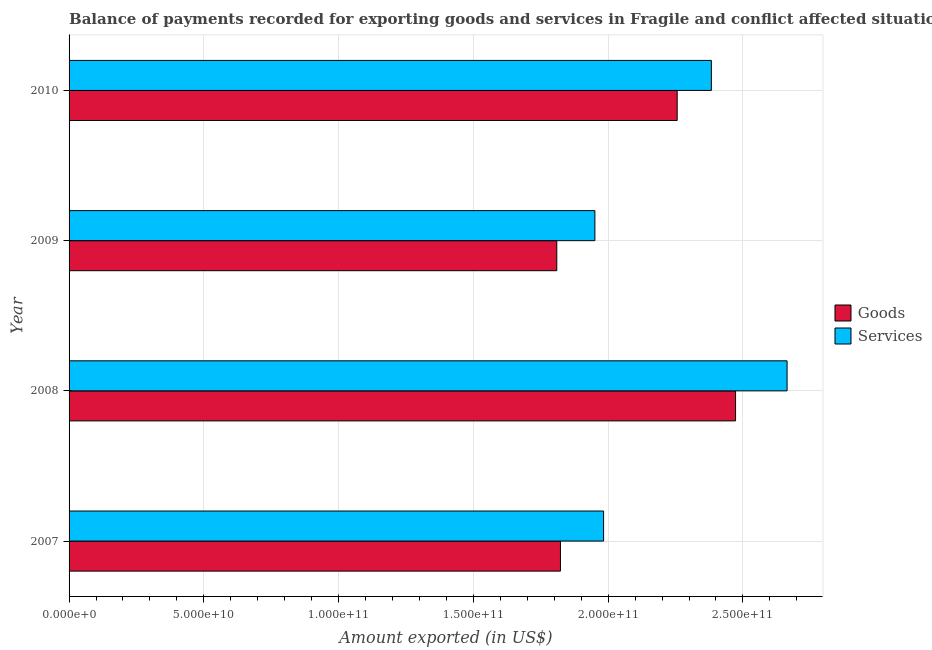How many different coloured bars are there?
Keep it short and to the point. 2. Are the number of bars per tick equal to the number of legend labels?
Keep it short and to the point. Yes. How many bars are there on the 4th tick from the top?
Offer a very short reply. 2. What is the label of the 2nd group of bars from the top?
Your answer should be very brief. 2009. In how many cases, is the number of bars for a given year not equal to the number of legend labels?
Your response must be concise. 0. What is the amount of services exported in 2010?
Your answer should be very brief. 2.38e+11. Across all years, what is the maximum amount of goods exported?
Ensure brevity in your answer.  2.47e+11. Across all years, what is the minimum amount of goods exported?
Offer a very short reply. 1.81e+11. What is the total amount of goods exported in the graph?
Provide a short and direct response. 8.36e+11. What is the difference between the amount of goods exported in 2008 and that in 2010?
Give a very brief answer. 2.17e+1. What is the difference between the amount of goods exported in 2009 and the amount of services exported in 2008?
Offer a very short reply. -8.54e+1. What is the average amount of services exported per year?
Ensure brevity in your answer.  2.25e+11. In the year 2008, what is the difference between the amount of goods exported and amount of services exported?
Keep it short and to the point. -1.91e+1. In how many years, is the amount of goods exported greater than 50000000000 US$?
Keep it short and to the point. 4. What is the ratio of the amount of services exported in 2007 to that in 2008?
Offer a terse response. 0.74. Is the difference between the amount of goods exported in 2008 and 2010 greater than the difference between the amount of services exported in 2008 and 2010?
Provide a short and direct response. No. What is the difference between the highest and the second highest amount of goods exported?
Your response must be concise. 2.17e+1. What is the difference between the highest and the lowest amount of goods exported?
Make the answer very short. 6.63e+1. What does the 1st bar from the top in 2010 represents?
Ensure brevity in your answer.  Services. What does the 2nd bar from the bottom in 2008 represents?
Make the answer very short. Services. How many bars are there?
Your answer should be very brief. 8. Are all the bars in the graph horizontal?
Ensure brevity in your answer.  Yes. Are the values on the major ticks of X-axis written in scientific E-notation?
Offer a terse response. Yes. How many legend labels are there?
Provide a succinct answer. 2. What is the title of the graph?
Provide a short and direct response. Balance of payments recorded for exporting goods and services in Fragile and conflict affected situations. Does "Male entrants" appear as one of the legend labels in the graph?
Give a very brief answer. No. What is the label or title of the X-axis?
Offer a terse response. Amount exported (in US$). What is the Amount exported (in US$) in Goods in 2007?
Offer a very short reply. 1.82e+11. What is the Amount exported (in US$) of Services in 2007?
Keep it short and to the point. 1.98e+11. What is the Amount exported (in US$) of Goods in 2008?
Provide a short and direct response. 2.47e+11. What is the Amount exported (in US$) of Services in 2008?
Your response must be concise. 2.66e+11. What is the Amount exported (in US$) of Goods in 2009?
Give a very brief answer. 1.81e+11. What is the Amount exported (in US$) of Services in 2009?
Offer a terse response. 1.95e+11. What is the Amount exported (in US$) of Goods in 2010?
Your response must be concise. 2.26e+11. What is the Amount exported (in US$) of Services in 2010?
Your answer should be compact. 2.38e+11. Across all years, what is the maximum Amount exported (in US$) in Goods?
Offer a very short reply. 2.47e+11. Across all years, what is the maximum Amount exported (in US$) of Services?
Make the answer very short. 2.66e+11. Across all years, what is the minimum Amount exported (in US$) in Goods?
Offer a terse response. 1.81e+11. Across all years, what is the minimum Amount exported (in US$) of Services?
Give a very brief answer. 1.95e+11. What is the total Amount exported (in US$) in Goods in the graph?
Your answer should be compact. 8.36e+11. What is the total Amount exported (in US$) in Services in the graph?
Your answer should be compact. 8.98e+11. What is the difference between the Amount exported (in US$) in Goods in 2007 and that in 2008?
Give a very brief answer. -6.50e+1. What is the difference between the Amount exported (in US$) in Services in 2007 and that in 2008?
Provide a short and direct response. -6.81e+1. What is the difference between the Amount exported (in US$) in Goods in 2007 and that in 2009?
Your answer should be very brief. 1.36e+09. What is the difference between the Amount exported (in US$) of Services in 2007 and that in 2009?
Your answer should be very brief. 3.23e+09. What is the difference between the Amount exported (in US$) in Goods in 2007 and that in 2010?
Your answer should be compact. -4.33e+1. What is the difference between the Amount exported (in US$) in Services in 2007 and that in 2010?
Ensure brevity in your answer.  -4.00e+1. What is the difference between the Amount exported (in US$) in Goods in 2008 and that in 2009?
Provide a short and direct response. 6.63e+1. What is the difference between the Amount exported (in US$) in Services in 2008 and that in 2009?
Offer a very short reply. 7.13e+1. What is the difference between the Amount exported (in US$) in Goods in 2008 and that in 2010?
Offer a terse response. 2.17e+1. What is the difference between the Amount exported (in US$) of Services in 2008 and that in 2010?
Give a very brief answer. 2.81e+1. What is the difference between the Amount exported (in US$) in Goods in 2009 and that in 2010?
Provide a short and direct response. -4.47e+1. What is the difference between the Amount exported (in US$) of Services in 2009 and that in 2010?
Provide a short and direct response. -4.32e+1. What is the difference between the Amount exported (in US$) in Goods in 2007 and the Amount exported (in US$) in Services in 2008?
Provide a succinct answer. -8.41e+1. What is the difference between the Amount exported (in US$) of Goods in 2007 and the Amount exported (in US$) of Services in 2009?
Offer a very short reply. -1.28e+1. What is the difference between the Amount exported (in US$) of Goods in 2007 and the Amount exported (in US$) of Services in 2010?
Your response must be concise. -5.60e+1. What is the difference between the Amount exported (in US$) in Goods in 2008 and the Amount exported (in US$) in Services in 2009?
Provide a succinct answer. 5.22e+1. What is the difference between the Amount exported (in US$) of Goods in 2008 and the Amount exported (in US$) of Services in 2010?
Your response must be concise. 8.98e+09. What is the difference between the Amount exported (in US$) in Goods in 2009 and the Amount exported (in US$) in Services in 2010?
Give a very brief answer. -5.73e+1. What is the average Amount exported (in US$) of Goods per year?
Provide a succinct answer. 2.09e+11. What is the average Amount exported (in US$) of Services per year?
Provide a succinct answer. 2.25e+11. In the year 2007, what is the difference between the Amount exported (in US$) of Goods and Amount exported (in US$) of Services?
Keep it short and to the point. -1.60e+1. In the year 2008, what is the difference between the Amount exported (in US$) in Goods and Amount exported (in US$) in Services?
Offer a very short reply. -1.91e+1. In the year 2009, what is the difference between the Amount exported (in US$) in Goods and Amount exported (in US$) in Services?
Your answer should be very brief. -1.41e+1. In the year 2010, what is the difference between the Amount exported (in US$) in Goods and Amount exported (in US$) in Services?
Your response must be concise. -1.27e+1. What is the ratio of the Amount exported (in US$) in Goods in 2007 to that in 2008?
Offer a terse response. 0.74. What is the ratio of the Amount exported (in US$) in Services in 2007 to that in 2008?
Keep it short and to the point. 0.74. What is the ratio of the Amount exported (in US$) in Goods in 2007 to that in 2009?
Make the answer very short. 1.01. What is the ratio of the Amount exported (in US$) of Services in 2007 to that in 2009?
Your answer should be very brief. 1.02. What is the ratio of the Amount exported (in US$) of Goods in 2007 to that in 2010?
Provide a short and direct response. 0.81. What is the ratio of the Amount exported (in US$) in Services in 2007 to that in 2010?
Offer a very short reply. 0.83. What is the ratio of the Amount exported (in US$) of Goods in 2008 to that in 2009?
Offer a very short reply. 1.37. What is the ratio of the Amount exported (in US$) in Services in 2008 to that in 2009?
Your answer should be very brief. 1.37. What is the ratio of the Amount exported (in US$) in Goods in 2008 to that in 2010?
Give a very brief answer. 1.1. What is the ratio of the Amount exported (in US$) in Services in 2008 to that in 2010?
Make the answer very short. 1.12. What is the ratio of the Amount exported (in US$) in Goods in 2009 to that in 2010?
Ensure brevity in your answer.  0.8. What is the ratio of the Amount exported (in US$) in Services in 2009 to that in 2010?
Your response must be concise. 0.82. What is the difference between the highest and the second highest Amount exported (in US$) of Goods?
Make the answer very short. 2.17e+1. What is the difference between the highest and the second highest Amount exported (in US$) of Services?
Give a very brief answer. 2.81e+1. What is the difference between the highest and the lowest Amount exported (in US$) of Goods?
Provide a short and direct response. 6.63e+1. What is the difference between the highest and the lowest Amount exported (in US$) of Services?
Ensure brevity in your answer.  7.13e+1. 